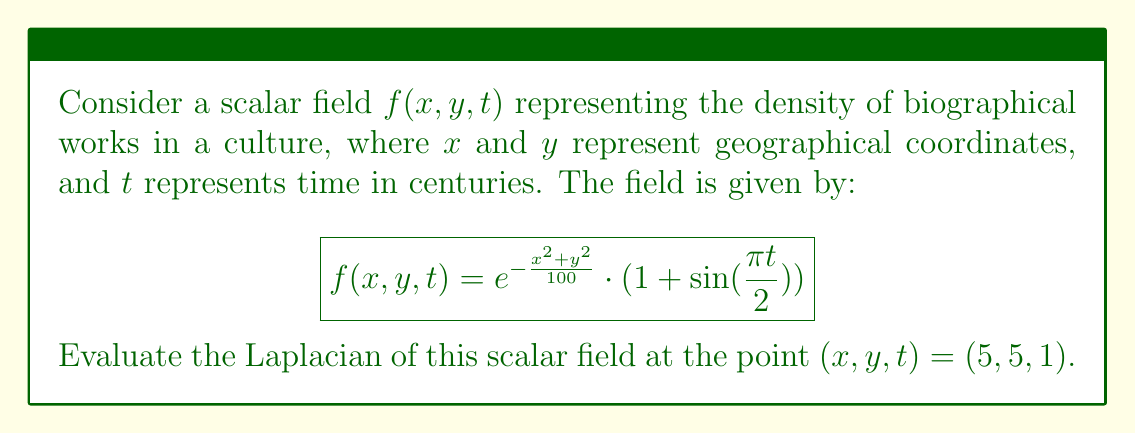Can you solve this math problem? To solve this problem, we'll follow these steps:

1) The Laplacian of a scalar field $f(x,y,t)$ in 3D is given by:

   $$\nabla^2f = \frac{\partial^2f}{\partial x^2} + \frac{\partial^2f}{\partial y^2} + \frac{\partial^2f}{\partial t^2}$$

2) Let's calculate each second partial derivative:

   a) $\frac{\partial f}{\partial x} = -\frac{2x}{100}e^{-\frac{x^2+y^2}{100}} \cdot (1 + \sin(\frac{\pi t}{2}))$
   
      $\frac{\partial^2 f}{\partial x^2} = (\frac{4x^2}{100^2} - \frac{2}{100})e^{-\frac{x^2+y^2}{100}} \cdot (1 + \sin(\frac{\pi t}{2}))$

   b) $\frac{\partial f}{\partial y} = -\frac{2y}{100}e^{-\frac{x^2+y^2}{100}} \cdot (1 + \sin(\frac{\pi t}{2}))$
   
      $\frac{\partial^2 f}{\partial y^2} = (\frac{4y^2}{100^2} - \frac{2}{100})e^{-\frac{x^2+y^2}{100}} \cdot (1 + \sin(\frac{\pi t}{2}))$

   c) $\frac{\partial f}{\partial t} = e^{-\frac{x^2+y^2}{100}} \cdot \frac{\pi}{2}\cos(\frac{\pi t}{2})$
   
      $\frac{\partial^2 f}{\partial t^2} = -e^{-\frac{x^2+y^2}{100}} \cdot \frac{\pi^2}{4}\sin(\frac{\pi t}{2})$

3) Now, we sum these second derivatives to get the Laplacian:

   $$\nabla^2f = (\frac{4x^2}{100^2} + \frac{4y^2}{100^2} - \frac{4}{100})e^{-\frac{x^2+y^2}{100}} \cdot (1 + \sin(\frac{\pi t}{2})) - e^{-\frac{x^2+y^2}{100}} \cdot \frac{\pi^2}{4}\sin(\frac{\pi t}{2})$$

4) Evaluate at the point $(x,y,t) = (5,5,1)$:

   $$\nabla^2f|_{(5,5,1)} = (\frac{4(5^2)}{100^2} + \frac{4(5^2)}{100^2} - \frac{4}{100})e^{-\frac{5^2+5^2}{100}} \cdot (1 + \sin(\frac{\pi}{2})) - e^{-\frac{5^2+5^2}{100}} \cdot \frac{\pi^2}{4}\sin(\frac{\pi}{2})$$

5) Simplify:

   $$\nabla^2f|_{(5,5,1)} = (0.02 - 0.04)e^{-0.5} \cdot 2 - e^{-0.5} \cdot \frac{\pi^2}{4}$$
   
   $$= -0.04e^{-0.5} - e^{-0.5} \cdot \frac{\pi^2}{4}$$
   
   $$= -e^{-0.5}(0.04 + \frac{\pi^2}{4}) \approx -1.9836$$
Answer: $-e^{-0.5}(0.04 + \frac{\pi^2}{4}) \approx -1.9836$ 